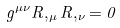<formula> <loc_0><loc_0><loc_500><loc_500>g ^ { \mu \nu } R , _ { \mu } R , _ { \nu } = 0</formula> 